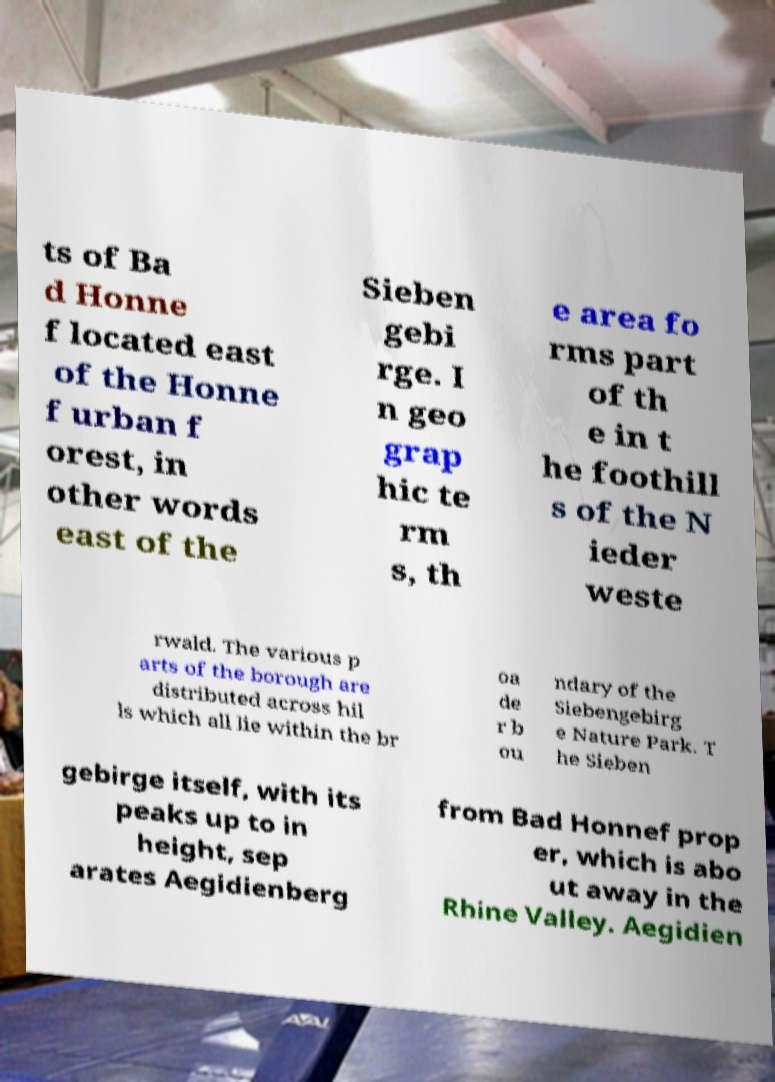Can you accurately transcribe the text from the provided image for me? ts of Ba d Honne f located east of the Honne f urban f orest, in other words east of the Sieben gebi rge. I n geo grap hic te rm s, th e area fo rms part of th e in t he foothill s of the N ieder weste rwald. The various p arts of the borough are distributed across hil ls which all lie within the br oa de r b ou ndary of the Siebengebirg e Nature Park. T he Sieben gebirge itself, with its peaks up to in height, sep arates Aegidienberg from Bad Honnef prop er, which is abo ut away in the Rhine Valley. Aegidien 